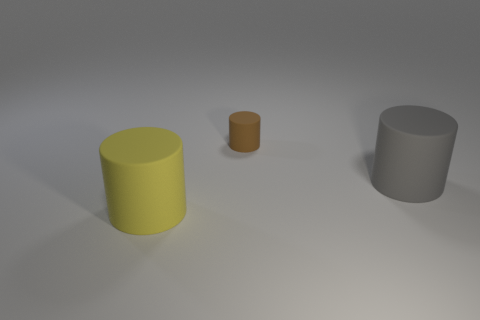There is a cylinder that is the same size as the gray rubber thing; what is its material?
Provide a succinct answer. Rubber. Is the number of big gray matte cylinders right of the large yellow matte thing less than the number of brown objects that are behind the tiny rubber thing?
Your response must be concise. No. There is a thing that is both right of the big yellow rubber object and in front of the small brown object; what shape is it?
Your response must be concise. Cylinder. How many other tiny things are the same shape as the gray object?
Ensure brevity in your answer.  1. There is a brown object that is made of the same material as the gray thing; what is its size?
Provide a succinct answer. Small. Is the number of large yellow cylinders greater than the number of small gray metal objects?
Your response must be concise. Yes. What color is the big object that is right of the big yellow object?
Your answer should be very brief. Gray. How big is the matte object that is both right of the big yellow matte thing and left of the large gray rubber cylinder?
Your response must be concise. Small. How many other gray matte objects have the same size as the gray thing?
Keep it short and to the point. 0. What material is the gray thing that is the same shape as the yellow rubber thing?
Your answer should be very brief. Rubber. 